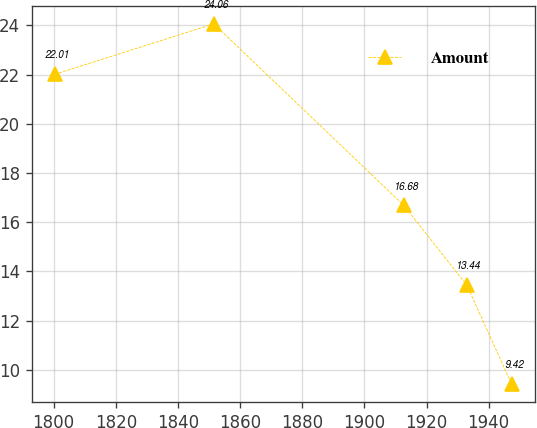<chart> <loc_0><loc_0><loc_500><loc_500><line_chart><ecel><fcel>Amount<nl><fcel>1800.35<fcel>22.01<nl><fcel>1851.53<fcel>24.06<nl><fcel>1912.72<fcel>16.68<nl><fcel>1932.97<fcel>13.44<nl><fcel>1947.41<fcel>9.42<nl></chart> 